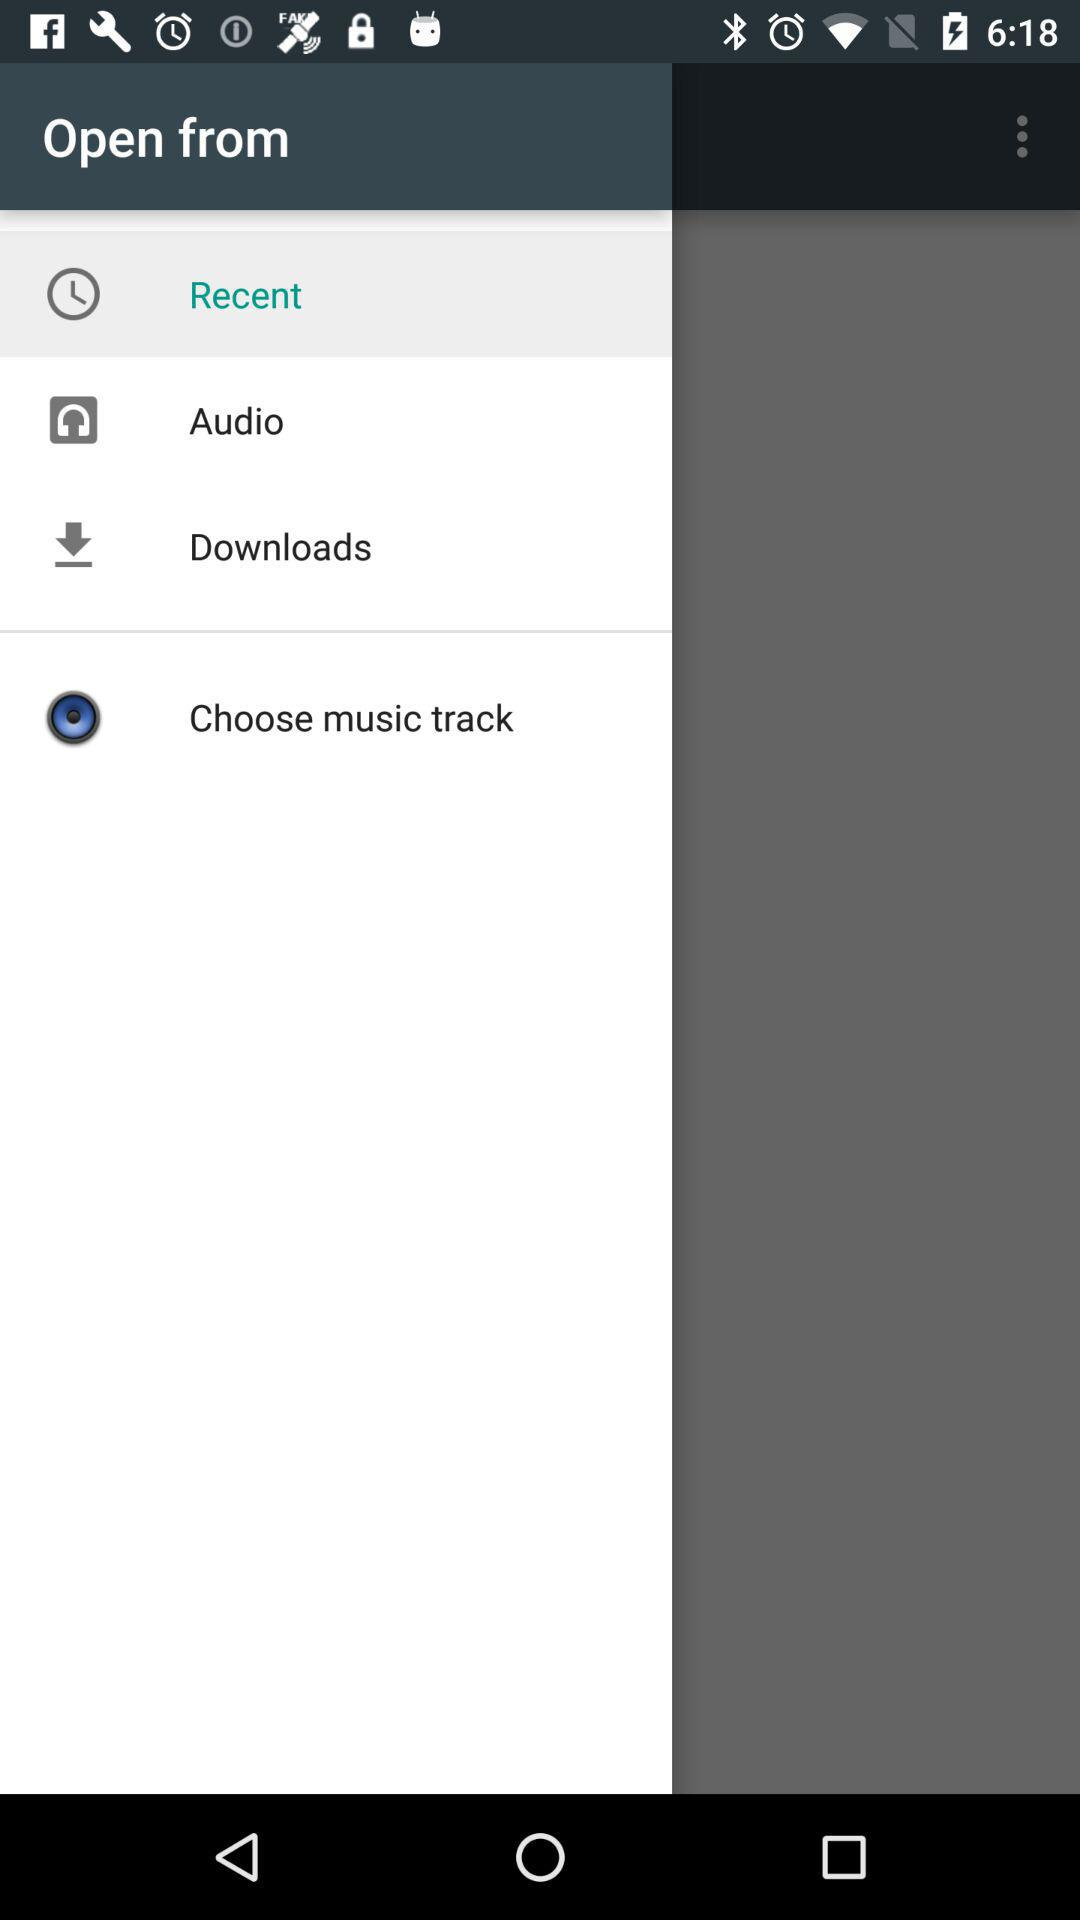What's the selected item? The selected item is "Recent". 